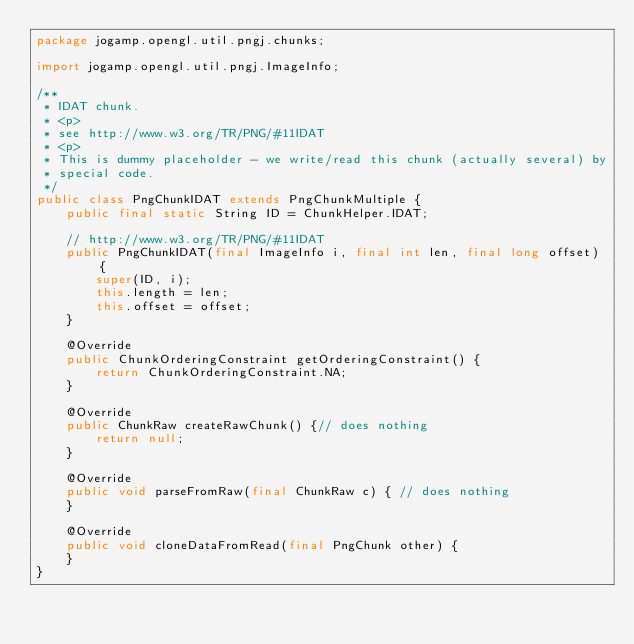<code> <loc_0><loc_0><loc_500><loc_500><_Java_>package jogamp.opengl.util.pngj.chunks;

import jogamp.opengl.util.pngj.ImageInfo;

/**
 * IDAT chunk.
 * <p>
 * see http://www.w3.org/TR/PNG/#11IDAT
 * <p>
 * This is dummy placeholder - we write/read this chunk (actually several) by
 * special code.
 */
public class PngChunkIDAT extends PngChunkMultiple {
	public final static String ID = ChunkHelper.IDAT;

	// http://www.w3.org/TR/PNG/#11IDAT
	public PngChunkIDAT(final ImageInfo i, final int len, final long offset) {
		super(ID, i);
		this.length = len;
		this.offset = offset;
	}

	@Override
	public ChunkOrderingConstraint getOrderingConstraint() {
		return ChunkOrderingConstraint.NA;
	}

	@Override
	public ChunkRaw createRawChunk() {// does nothing
		return null;
	}

	@Override
	public void parseFromRaw(final ChunkRaw c) { // does nothing
	}

	@Override
	public void cloneDataFromRead(final PngChunk other) {
	}
}
</code> 